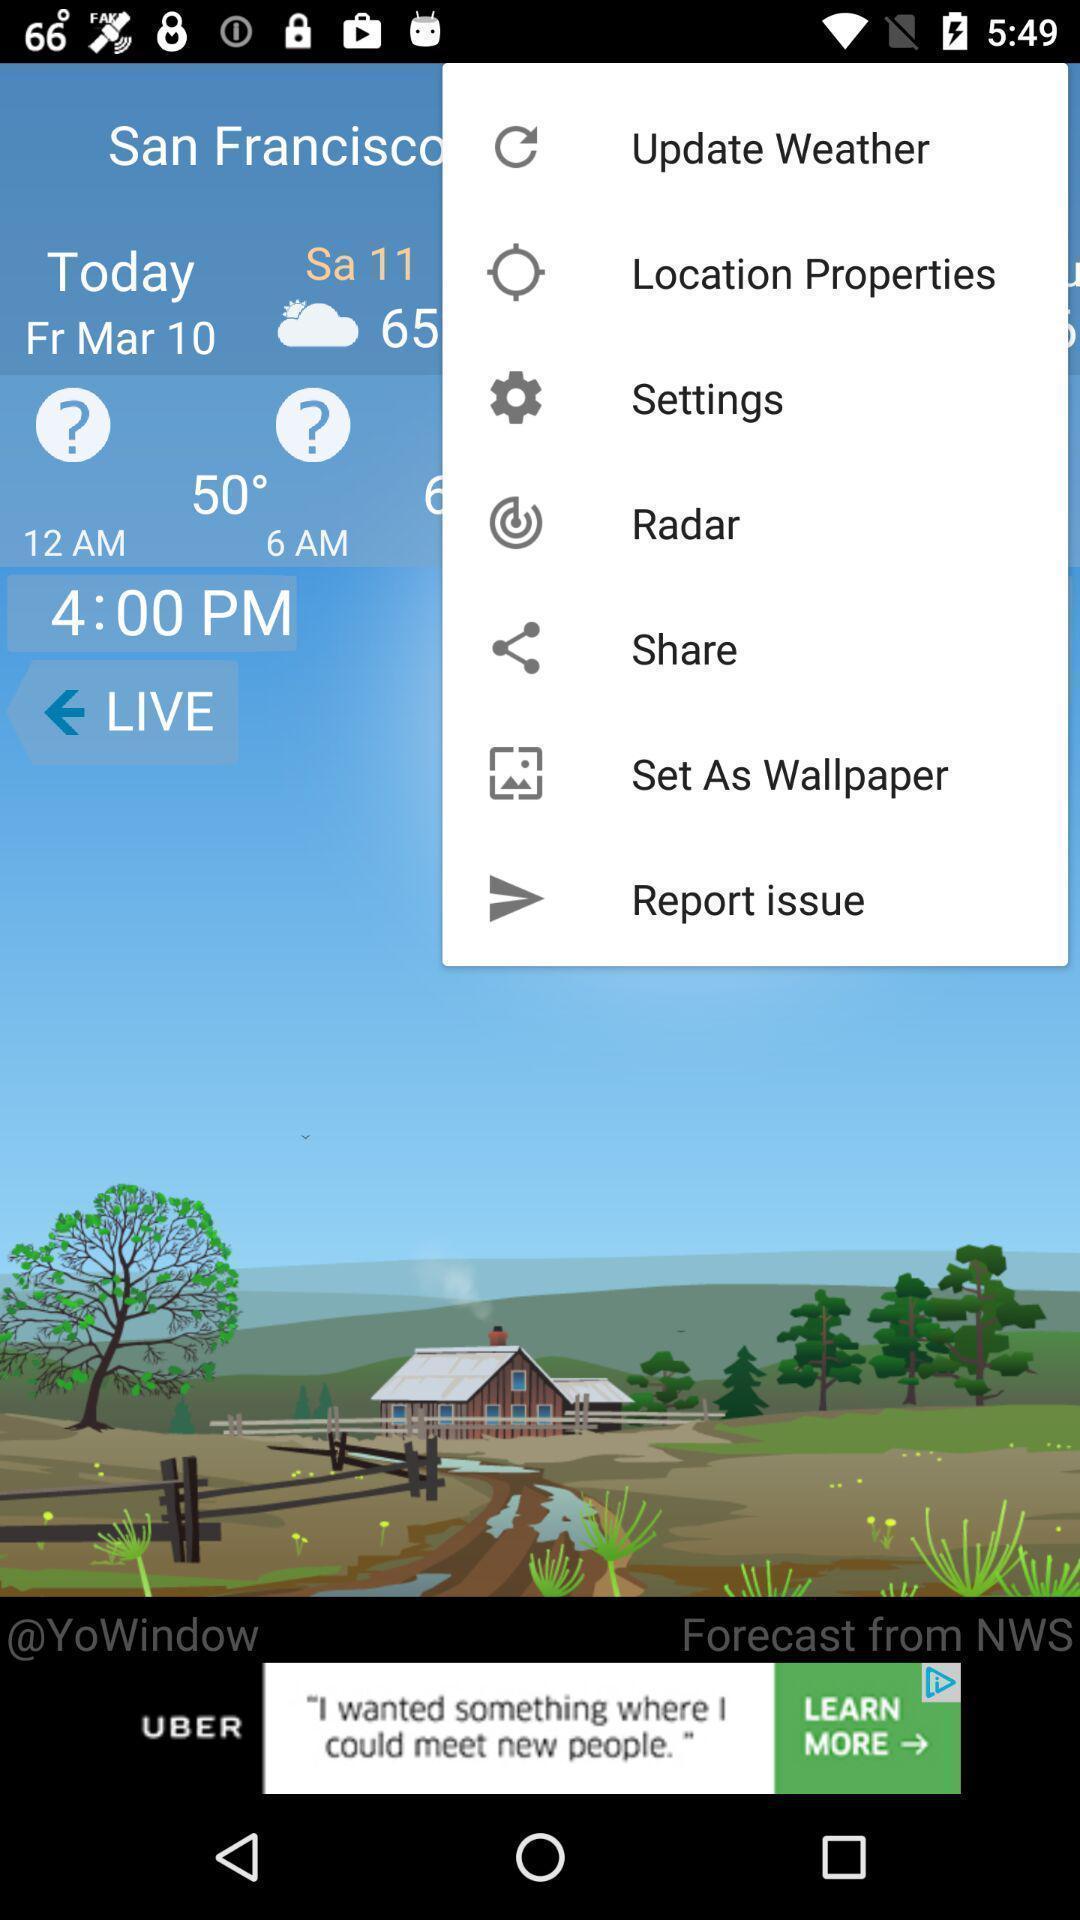What can you discern from this picture? Page with different options of a weather app. 